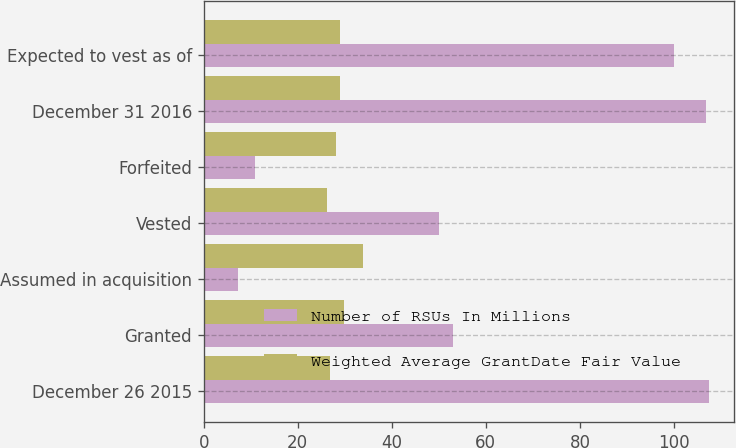<chart> <loc_0><loc_0><loc_500><loc_500><stacked_bar_chart><ecel><fcel>December 26 2015<fcel>Granted<fcel>Assumed in acquisition<fcel>Vested<fcel>Forfeited<fcel>December 31 2016<fcel>Expected to vest as of<nl><fcel>Number of RSUs In Millions<fcel>107.4<fcel>53.1<fcel>7.3<fcel>50<fcel>11<fcel>106.8<fcel>99.9<nl><fcel>Weighted Average GrantDate Fair Value<fcel>26.93<fcel>29.76<fcel>33.79<fcel>26.29<fcel>28.1<fcel>28.99<fcel>28.99<nl></chart> 